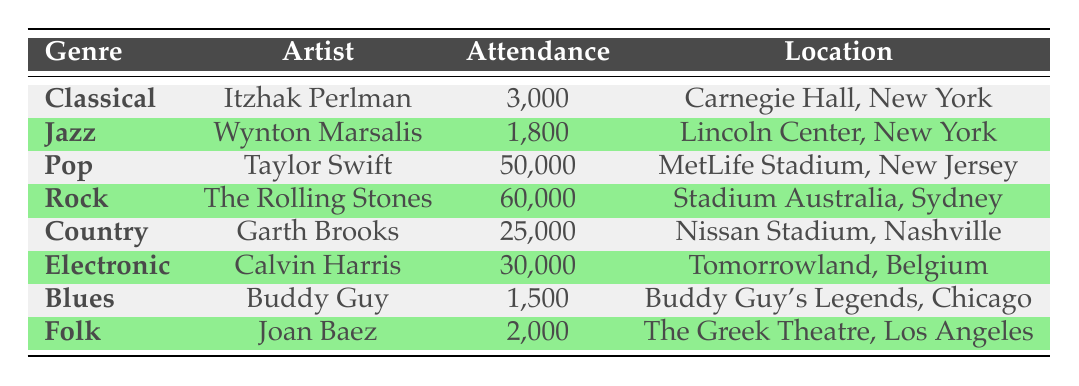What is the highest attendance recorded in the table? The highest attendance is found by comparing all the values in the "Attendance" column. The different attendance figures are 3,000 (Classical), 1,800 (Jazz), 50,000 (Pop), 60,000 (Rock), 25,000 (Country), 30,000 (Electronic), 1,500 (Blues), and 2,000 (Folk). The greatest of these is 60,000 for Rock.
Answer: 60,000 Which genre had the lowest attendance? To find the lowest attendance, I compare all the attendance values. The figures listed are 3,000, 1,800, 50,000, 60,000, 25,000, 30,000, 1,500, and 2,000. The lowest attendance is 1,500 from the Blues genre.
Answer: Blues Is it true that Jazz had more attendance than Folk? Comparing the two attendance values, Jazz has 1,800 while Folk has 2,000. Since 1,800 is less than 2,000, the statement is false.
Answer: No What is the total attendance for all genres combined? To determine the total attendance, I need to sum all attendance values: 3,000 + 1,800 + 50,000 + 60,000 + 25,000 + 30,000 + 1,500 + 2,000 = 173,300.
Answer: 173,300 How many genres had an attendance of over 20,000? I check each genre's attendance to see which ones exceed 20,000: Pop (50,000), Rock (60,000), Country (25,000), and Electronic (30,000). There are four genres fulfilling this criterion.
Answer: 4 What percentage of the total attendance was made up by Pop? The attendance for Pop is 50,000, and the total attendance is 173,300. To find the percentage: (50,000 / 173,300) * 100 ≈ 28.87%.
Answer: 28.87% Which city hosted the most popular attendance among genres and what was the attendance? From the data, the artist with the highest attendance is The Rolling Stones at 60,000, held in Stadium Australia, Sydney. Thus, the answer pertains to this location and attendance.
Answer: Stadium Australia, Sydney; 60,000 If we look at Folk and Blues combined, how much attendance do they have? Folk had 2,000 attendees and Blues had 1,500. Adding them gives a combined attendance of 2,000 + 1,500 = 3,500.
Answer: 3,500 